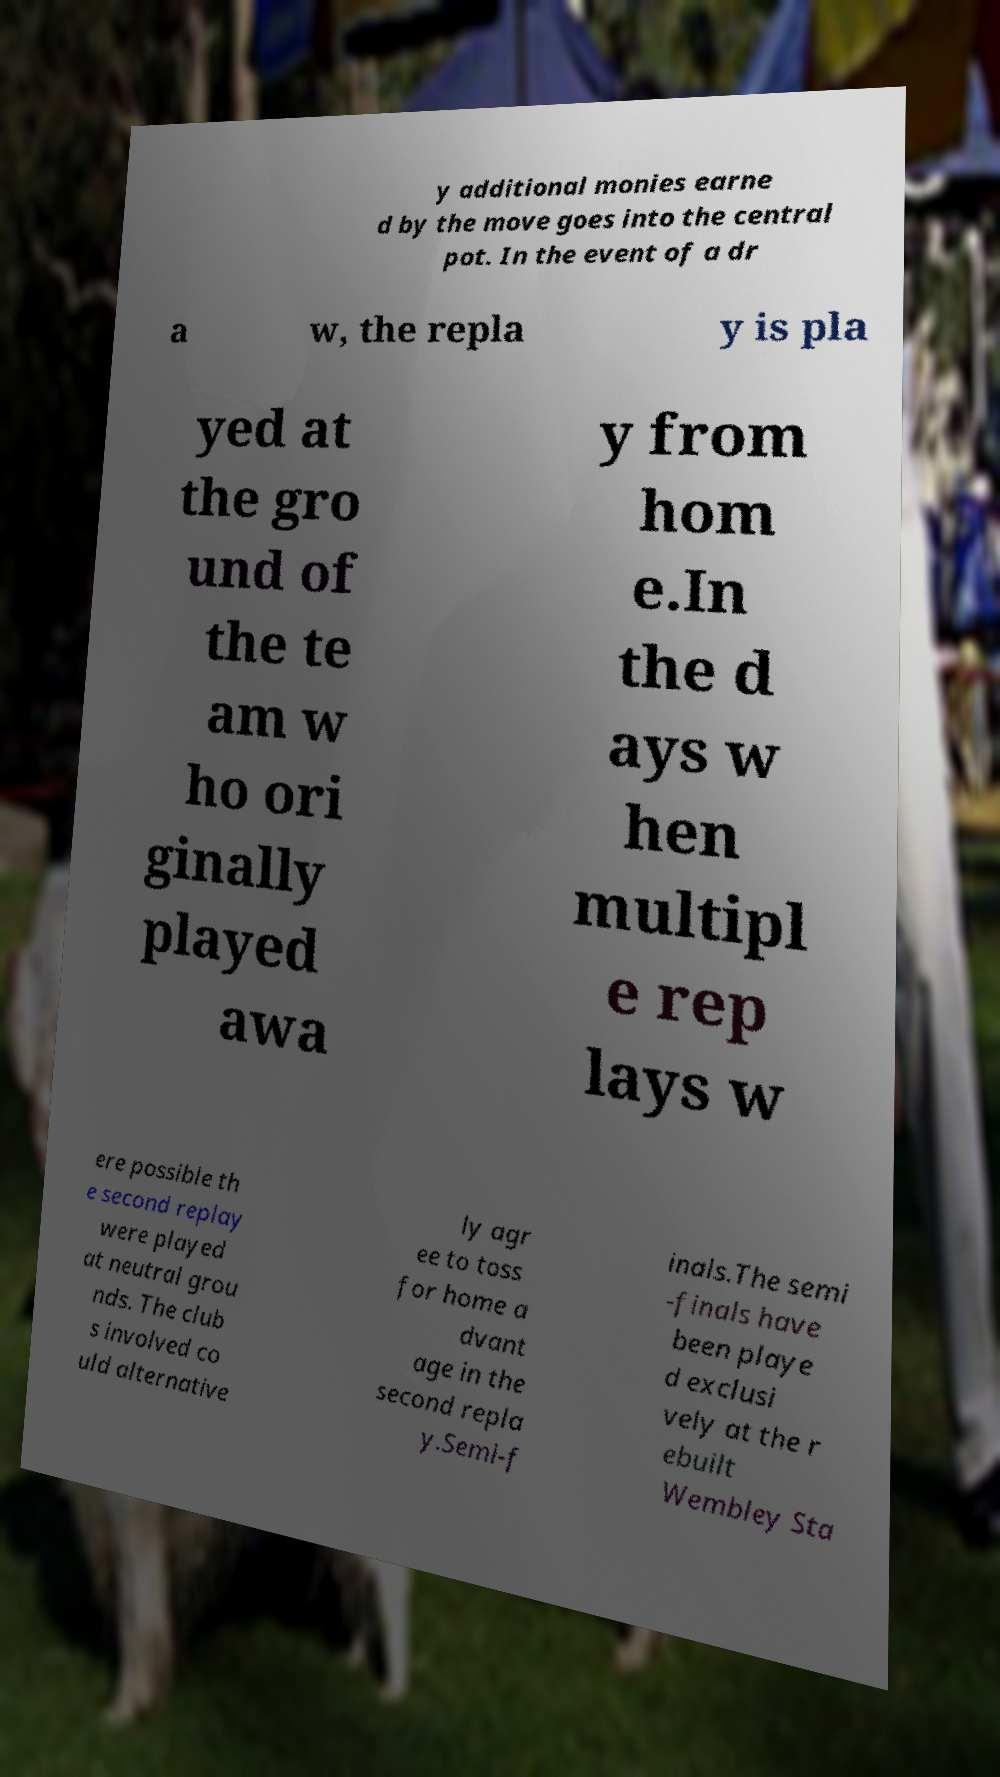Please read and relay the text visible in this image. What does it say? y additional monies earne d by the move goes into the central pot. In the event of a dr a w, the repla y is pla yed at the gro und of the te am w ho ori ginally played awa y from hom e.In the d ays w hen multipl e rep lays w ere possible th e second replay were played at neutral grou nds. The club s involved co uld alternative ly agr ee to toss for home a dvant age in the second repla y.Semi-f inals.The semi -finals have been playe d exclusi vely at the r ebuilt Wembley Sta 